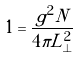<formula> <loc_0><loc_0><loc_500><loc_500>1 = \frac { g ^ { 2 } N } { 4 \pi L _ { \perp } ^ { 2 } }</formula> 